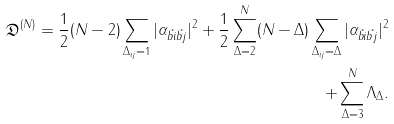<formula> <loc_0><loc_0><loc_500><loc_500>\mathfrak { D } ^ { ( N ) } = \frac { 1 } { 2 } ( N - 2 ) \sum _ { \Delta _ { i j } = 1 } | \alpha _ { \vec { b } { i } \vec { b } { j } } | ^ { 2 } + \frac { 1 } { 2 } \sum _ { \Delta = 2 } ^ { N } ( N - \Delta ) \sum _ { \Delta _ { i j } = \Delta } | \alpha _ { \vec { b } { i } \vec { b } { j } } | ^ { 2 } \\ + \sum _ { \Delta = 3 } ^ { N } \Lambda _ { \Delta } .</formula> 